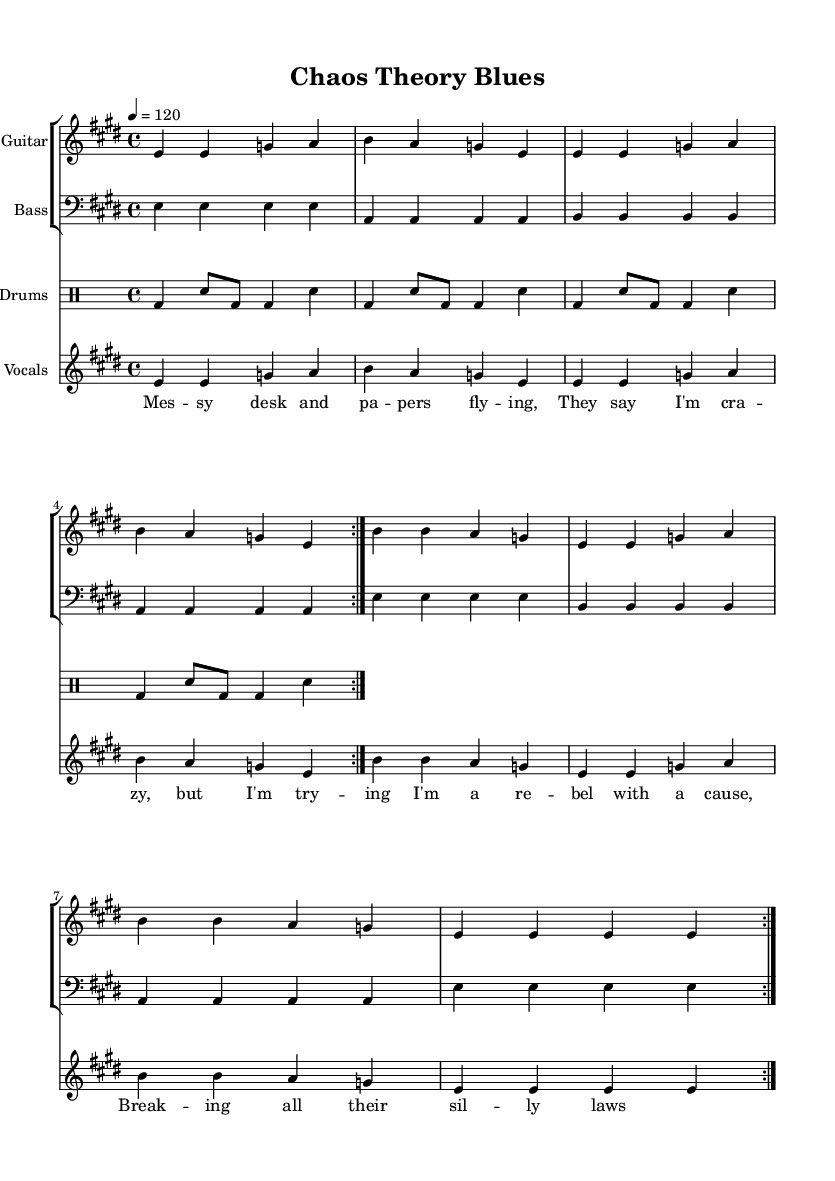What is the key signature of this music? The key signature is E major, which has four sharps (F#, C#, G#, D#). This can be determined by locating the key signature at the beginning of the staff, right after the clef.
Answer: E major What is the time signature of this music? The time signature is 4/4, which indicates there are four beats in each measure and a quarter note receives one beat. This can be identified at the beginning of the sheet music next to the key signature.
Answer: 4/4 What is the tempo marking for this piece? The tempo marking is 120, which means the piece is to be played at 120 beats per minute. This is noted in the tempo indication at the start of the piece.
Answer: 120 How many times does the verse repeat? The verse is repeated two times, which is indicated by the "volta 2" notation in the guitar and bass music, meaning that those sections will be played twice.
Answer: 2 What instrument plays the main melody? The instrument that plays the main melody is the guitar. This is deduced from the labeled staff named "Guitar" where the melody notes are written.
Answer: Guitar What lyrical theme does this piece embody? The lyrical theme embodies rebellion and individuality, as seen in phrases like "I'm a rebel with a cause" and "breaking all their silly laws". This theme can be deduced from the content of the lyrics provided alongside the melody.
Answer: Rebellion What role does the drum part play in this genre? The drum part provides a driving rhythm that is characteristic of Electric Blues, emphasizing the beat with kick and snare patterns. This can be inferred from the rhythmic structure of the drum part which supports the overall groove of the music.
Answer: Driving rhythm 